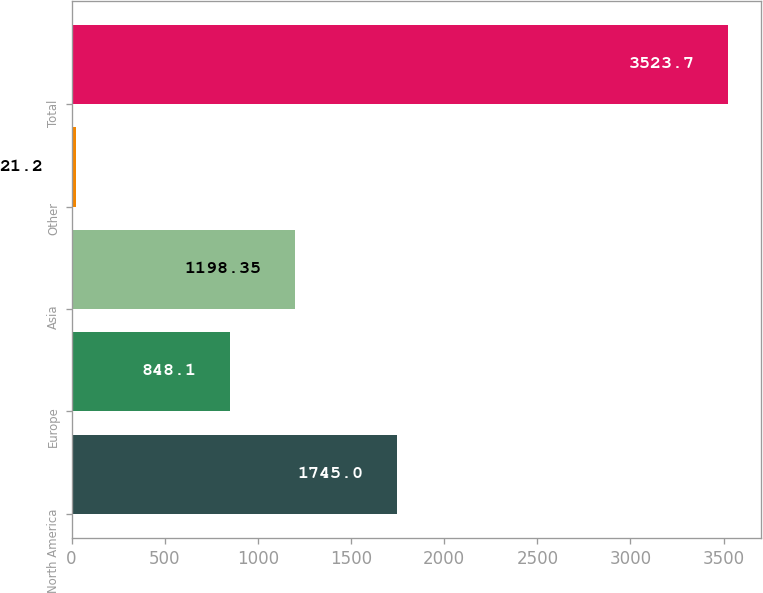<chart> <loc_0><loc_0><loc_500><loc_500><bar_chart><fcel>North America<fcel>Europe<fcel>Asia<fcel>Other<fcel>Total<nl><fcel>1745<fcel>848.1<fcel>1198.35<fcel>21.2<fcel>3523.7<nl></chart> 